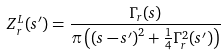Convert formula to latex. <formula><loc_0><loc_0><loc_500><loc_500>Z _ { r } ^ { L } ( s ^ { \prime } ) = \frac { \Gamma _ { r } ( s ) } { \pi \left ( \left ( s - s ^ { \prime } \right ) ^ { 2 } + \frac { 1 } { 4 } \Gamma _ { r } ^ { 2 } ( s ^ { \prime } ) \right ) }</formula> 